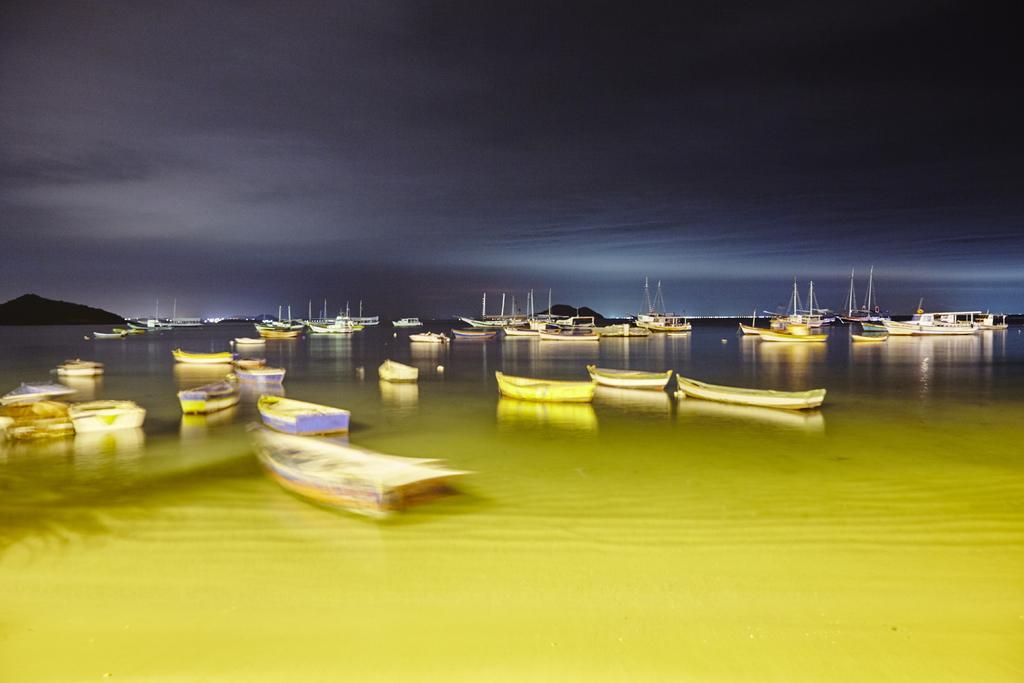Can you describe this image briefly? In this picture we can see ships and boats on the water. On the background we can see mountains. On the top we can see sky and clouds. Here we can see bridge. 